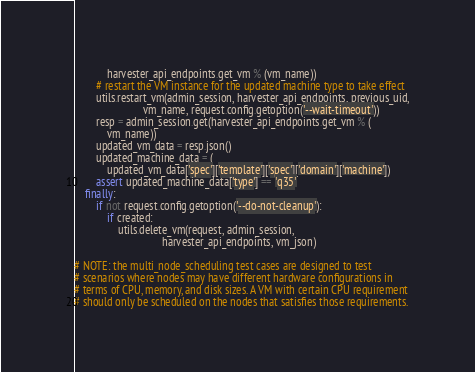<code> <loc_0><loc_0><loc_500><loc_500><_Python_>            harvester_api_endpoints.get_vm % (vm_name))
        # restart the VM instance for the updated machine type to take effect
        utils.restart_vm(admin_session, harvester_api_endpoints, previous_uid,
                         vm_name, request.config.getoption('--wait-timeout'))
        resp = admin_session.get(harvester_api_endpoints.get_vm % (
            vm_name))
        updated_vm_data = resp.json()
        updated_machine_data = (
            updated_vm_data['spec']['template']['spec']['domain']['machine'])
        assert updated_machine_data['type'] == 'q35'
    finally:
        if not request.config.getoption('--do-not-cleanup'):
            if created:
                utils.delete_vm(request, admin_session,
                                harvester_api_endpoints, vm_json)

# NOTE: the multi_node_scheduling test cases are designed to test
# scenarios where nodes may have different hardware configurations in
# terms of CPU, memory, and disk sizes. A VM with certain CPU requirement
# should only be scheduled on the nodes that satisfies those requirements.</code> 